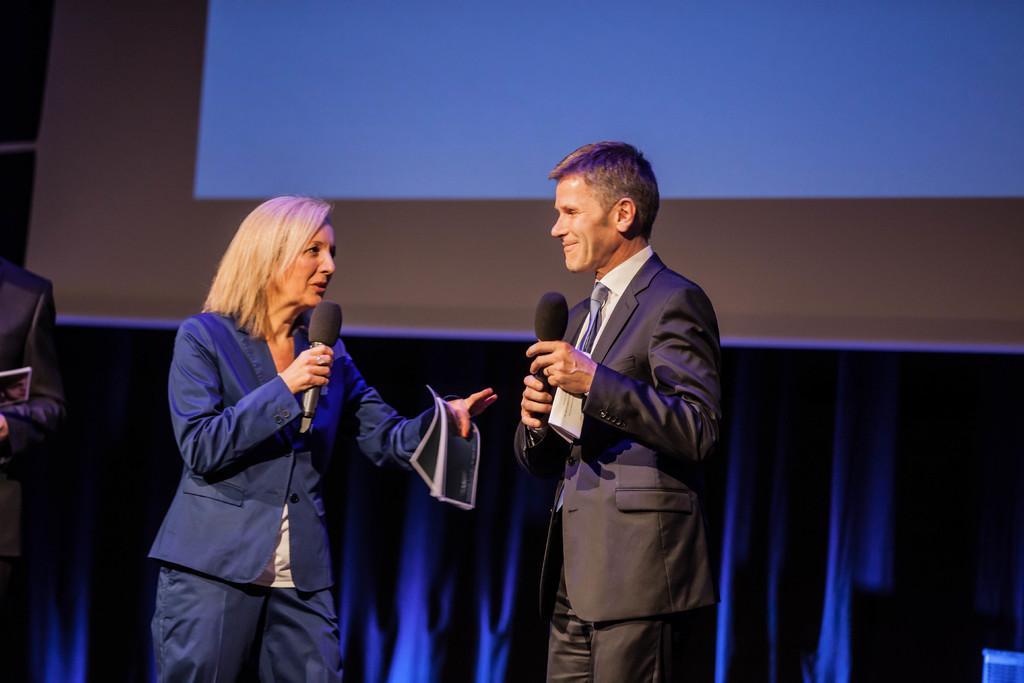In one or two sentences, can you explain what this image depicts? A couple is standing wearing suit, holding microphone and paper. 